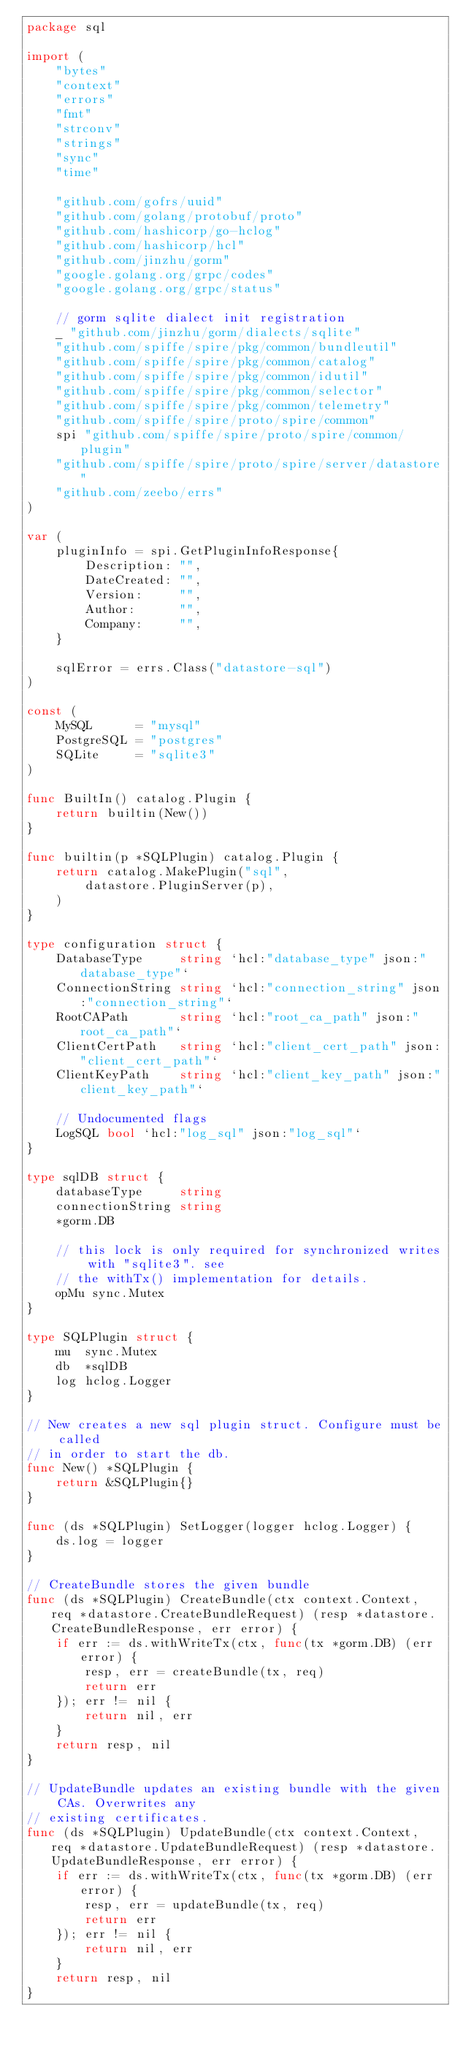Convert code to text. <code><loc_0><loc_0><loc_500><loc_500><_Go_>package sql

import (
	"bytes"
	"context"
	"errors"
	"fmt"
	"strconv"
	"strings"
	"sync"
	"time"

	"github.com/gofrs/uuid"
	"github.com/golang/protobuf/proto"
	"github.com/hashicorp/go-hclog"
	"github.com/hashicorp/hcl"
	"github.com/jinzhu/gorm"
	"google.golang.org/grpc/codes"
	"google.golang.org/grpc/status"

	// gorm sqlite dialect init registration
	_ "github.com/jinzhu/gorm/dialects/sqlite"
	"github.com/spiffe/spire/pkg/common/bundleutil"
	"github.com/spiffe/spire/pkg/common/catalog"
	"github.com/spiffe/spire/pkg/common/idutil"
	"github.com/spiffe/spire/pkg/common/selector"
	"github.com/spiffe/spire/pkg/common/telemetry"
	"github.com/spiffe/spire/proto/spire/common"
	spi "github.com/spiffe/spire/proto/spire/common/plugin"
	"github.com/spiffe/spire/proto/spire/server/datastore"
	"github.com/zeebo/errs"
)

var (
	pluginInfo = spi.GetPluginInfoResponse{
		Description: "",
		DateCreated: "",
		Version:     "",
		Author:      "",
		Company:     "",
	}

	sqlError = errs.Class("datastore-sql")
)

const (
	MySQL      = "mysql"
	PostgreSQL = "postgres"
	SQLite     = "sqlite3"
)

func BuiltIn() catalog.Plugin {
	return builtin(New())
}

func builtin(p *SQLPlugin) catalog.Plugin {
	return catalog.MakePlugin("sql",
		datastore.PluginServer(p),
	)
}

type configuration struct {
	DatabaseType     string `hcl:"database_type" json:"database_type"`
	ConnectionString string `hcl:"connection_string" json:"connection_string"`
	RootCAPath       string `hcl:"root_ca_path" json:"root_ca_path"`
	ClientCertPath   string `hcl:"client_cert_path" json:"client_cert_path"`
	ClientKeyPath    string `hcl:"client_key_path" json:"client_key_path"`

	// Undocumented flags
	LogSQL bool `hcl:"log_sql" json:"log_sql"`
}

type sqlDB struct {
	databaseType     string
	connectionString string
	*gorm.DB

	// this lock is only required for synchronized writes with "sqlite3". see
	// the withTx() implementation for details.
	opMu sync.Mutex
}

type SQLPlugin struct {
	mu  sync.Mutex
	db  *sqlDB
	log hclog.Logger
}

// New creates a new sql plugin struct. Configure must be called
// in order to start the db.
func New() *SQLPlugin {
	return &SQLPlugin{}
}

func (ds *SQLPlugin) SetLogger(logger hclog.Logger) {
	ds.log = logger
}

// CreateBundle stores the given bundle
func (ds *SQLPlugin) CreateBundle(ctx context.Context, req *datastore.CreateBundleRequest) (resp *datastore.CreateBundleResponse, err error) {
	if err := ds.withWriteTx(ctx, func(tx *gorm.DB) (err error) {
		resp, err = createBundle(tx, req)
		return err
	}); err != nil {
		return nil, err
	}
	return resp, nil
}

// UpdateBundle updates an existing bundle with the given CAs. Overwrites any
// existing certificates.
func (ds *SQLPlugin) UpdateBundle(ctx context.Context, req *datastore.UpdateBundleRequest) (resp *datastore.UpdateBundleResponse, err error) {
	if err := ds.withWriteTx(ctx, func(tx *gorm.DB) (err error) {
		resp, err = updateBundle(tx, req)
		return err
	}); err != nil {
		return nil, err
	}
	return resp, nil
}
</code> 